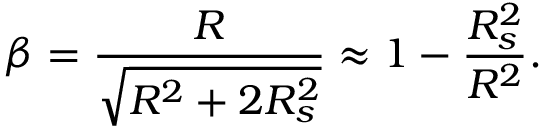Convert formula to latex. <formula><loc_0><loc_0><loc_500><loc_500>\beta = { \frac { R } { \sqrt { R ^ { 2 } + 2 R _ { s } ^ { 2 } } } } \approx 1 - { \frac { R _ { s } ^ { 2 } } { R ^ { 2 } } } .</formula> 